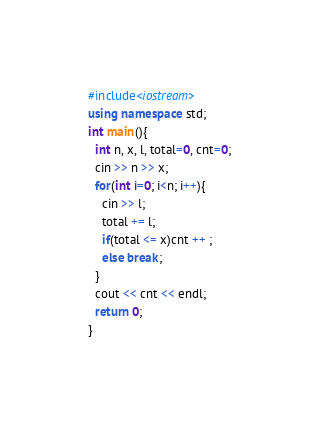<code> <loc_0><loc_0><loc_500><loc_500><_C++_>#include<iostream>
using namespace std;
int main(){
  int n, x, l, total=0, cnt=0;
  cin >> n >> x;
  for(int i=0; i<n; i++){
    cin >> l;
    total += l;
    if(total <= x)cnt ++ ;
    else break;
  }
  cout << cnt << endl;
  return 0;
}

</code> 